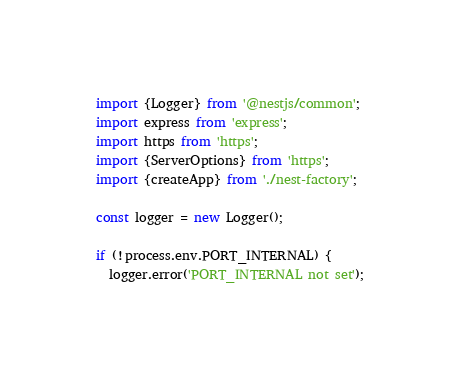Convert code to text. <code><loc_0><loc_0><loc_500><loc_500><_TypeScript_>import {Logger} from '@nestjs/common';
import express from 'express';
import https from 'https';
import {ServerOptions} from 'https';
import {createApp} from './nest-factory';

const logger = new Logger();

if (!process.env.PORT_INTERNAL) {
  logger.error('PORT_INTERNAL not set');</code> 